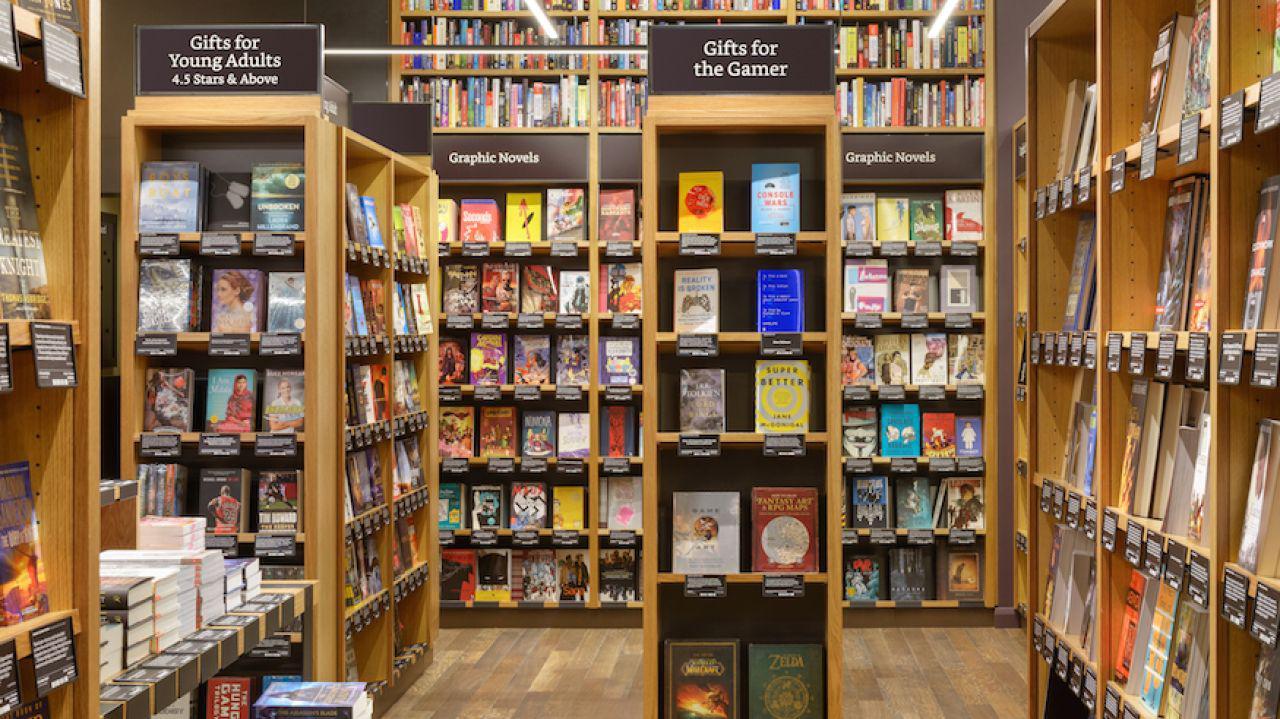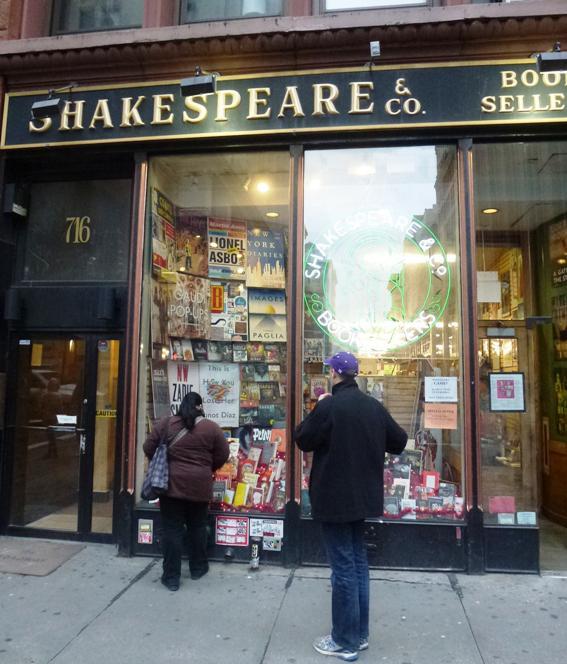The first image is the image on the left, the second image is the image on the right. For the images shown, is this caption "Red rectangular signs with white lettering are displayed above ground-level in one scene." true? Answer yes or no. No. 